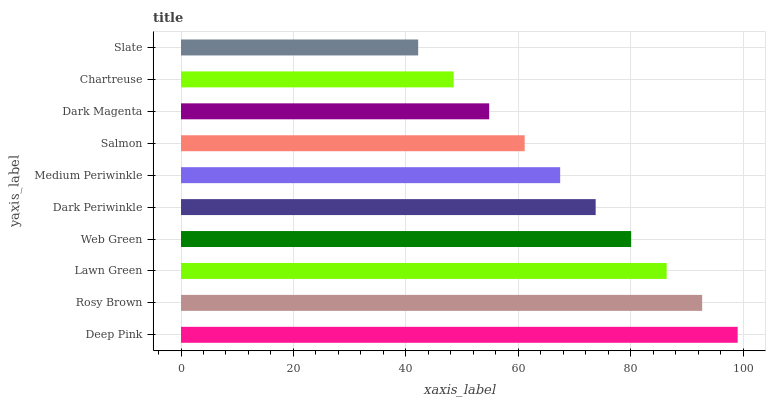Is Slate the minimum?
Answer yes or no. Yes. Is Deep Pink the maximum?
Answer yes or no. Yes. Is Rosy Brown the minimum?
Answer yes or no. No. Is Rosy Brown the maximum?
Answer yes or no. No. Is Deep Pink greater than Rosy Brown?
Answer yes or no. Yes. Is Rosy Brown less than Deep Pink?
Answer yes or no. Yes. Is Rosy Brown greater than Deep Pink?
Answer yes or no. No. Is Deep Pink less than Rosy Brown?
Answer yes or no. No. Is Dark Periwinkle the high median?
Answer yes or no. Yes. Is Medium Periwinkle the low median?
Answer yes or no. Yes. Is Lawn Green the high median?
Answer yes or no. No. Is Deep Pink the low median?
Answer yes or no. No. 